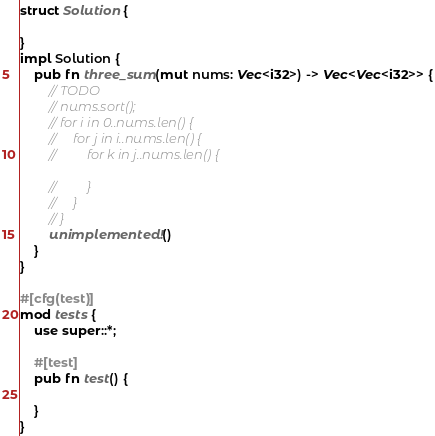Convert code to text. <code><loc_0><loc_0><loc_500><loc_500><_Rust_>struct Solution {

}
impl Solution {
    pub fn three_sum(mut nums: Vec<i32>) -> Vec<Vec<i32>> {
        // TODO
        // nums.sort();
        // for i in 0..nums.len() {
        //     for j in i..nums.len() {
        //         for k in j..nums.len() {

        //         }
        //     }
        // }
        unimplemented!()
    }
}

#[cfg(test)]
mod tests {
    use super::*;

    #[test]
    pub fn test() {

    }
}
</code> 